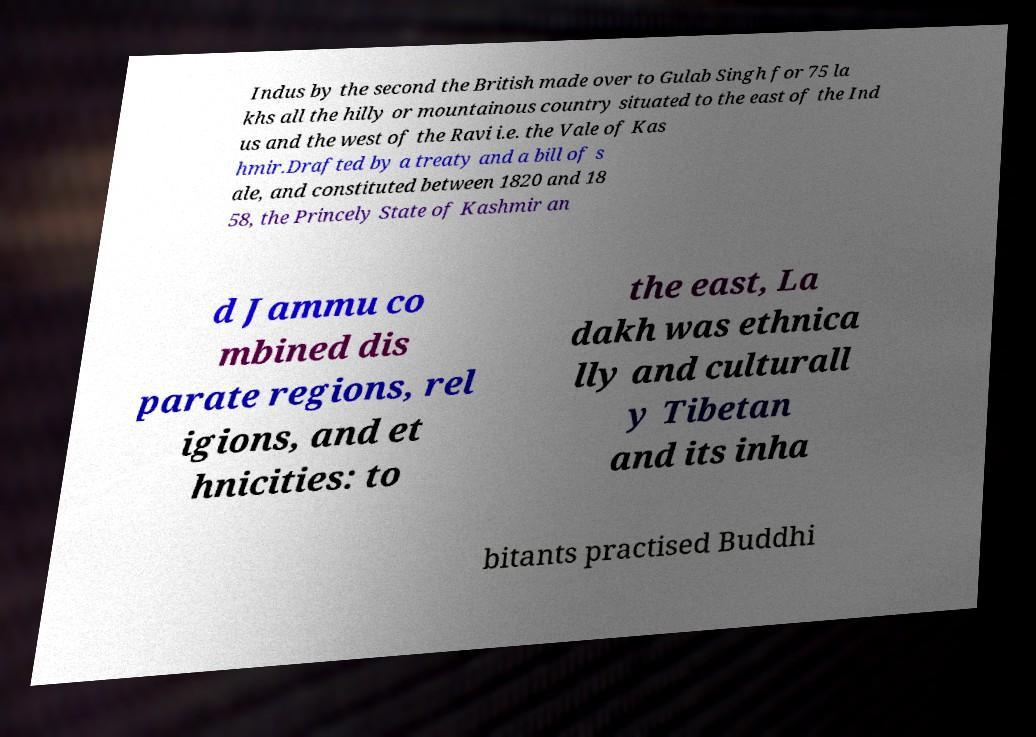Please read and relay the text visible in this image. What does it say? Indus by the second the British made over to Gulab Singh for 75 la khs all the hilly or mountainous country situated to the east of the Ind us and the west of the Ravi i.e. the Vale of Kas hmir.Drafted by a treaty and a bill of s ale, and constituted between 1820 and 18 58, the Princely State of Kashmir an d Jammu co mbined dis parate regions, rel igions, and et hnicities: to the east, La dakh was ethnica lly and culturall y Tibetan and its inha bitants practised Buddhi 